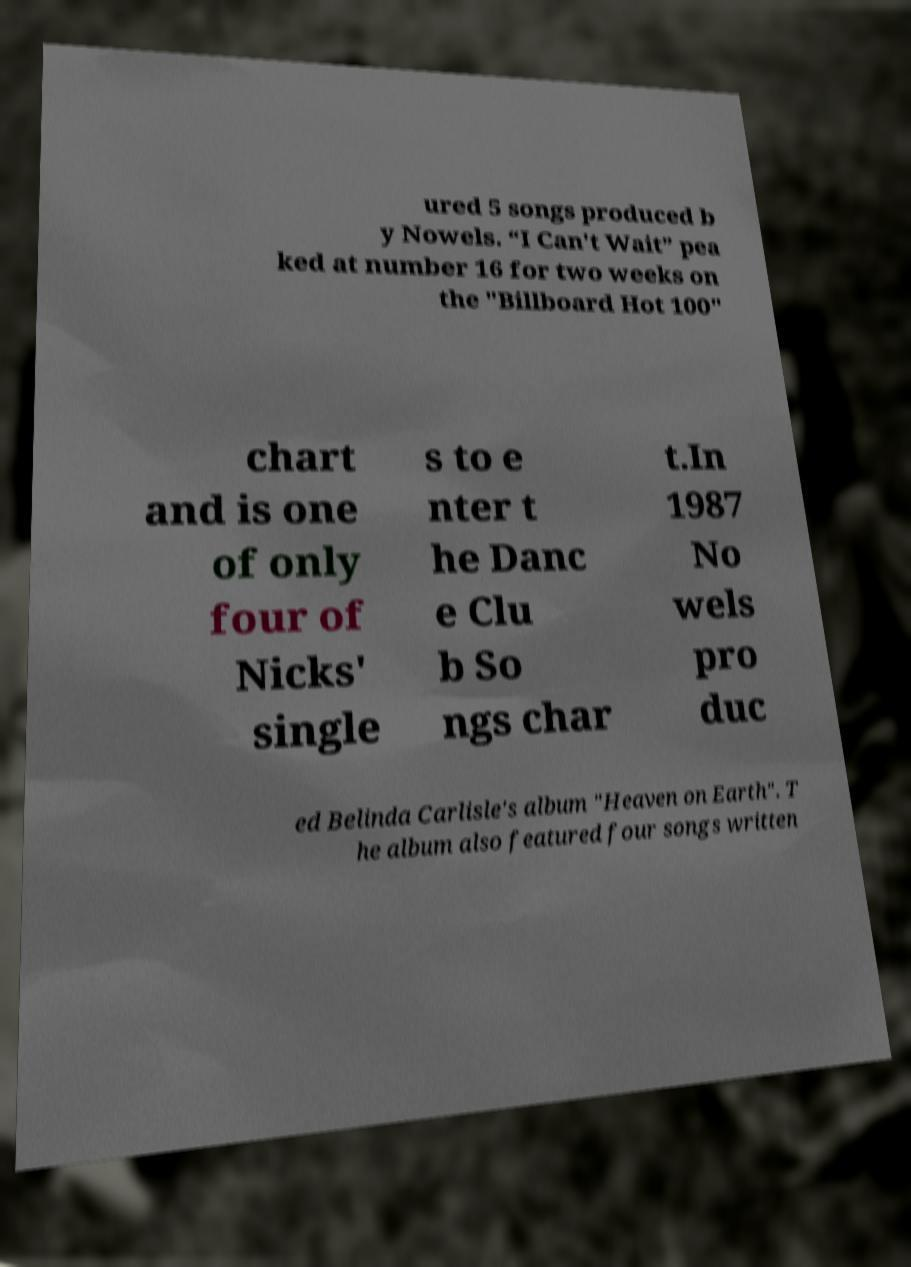I need the written content from this picture converted into text. Can you do that? ured 5 songs produced b y Nowels. “I Can't Wait” pea ked at number 16 for two weeks on the "Billboard Hot 100" chart and is one of only four of Nicks' single s to e nter t he Danc e Clu b So ngs char t.In 1987 No wels pro duc ed Belinda Carlisle's album "Heaven on Earth". T he album also featured four songs written 